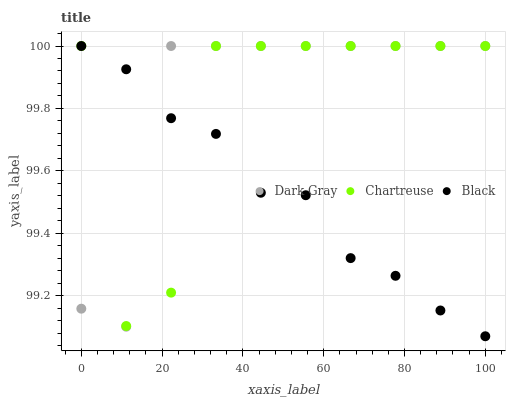Does Black have the minimum area under the curve?
Answer yes or no. Yes. Does Dark Gray have the maximum area under the curve?
Answer yes or no. Yes. Does Chartreuse have the minimum area under the curve?
Answer yes or no. No. Does Chartreuse have the maximum area under the curve?
Answer yes or no. No. Is Black the smoothest?
Answer yes or no. Yes. Is Chartreuse the roughest?
Answer yes or no. Yes. Is Chartreuse the smoothest?
Answer yes or no. No. Is Black the roughest?
Answer yes or no. No. Does Black have the lowest value?
Answer yes or no. Yes. Does Chartreuse have the lowest value?
Answer yes or no. No. Does Black have the highest value?
Answer yes or no. Yes. Does Chartreuse intersect Dark Gray?
Answer yes or no. Yes. Is Chartreuse less than Dark Gray?
Answer yes or no. No. Is Chartreuse greater than Dark Gray?
Answer yes or no. No. 